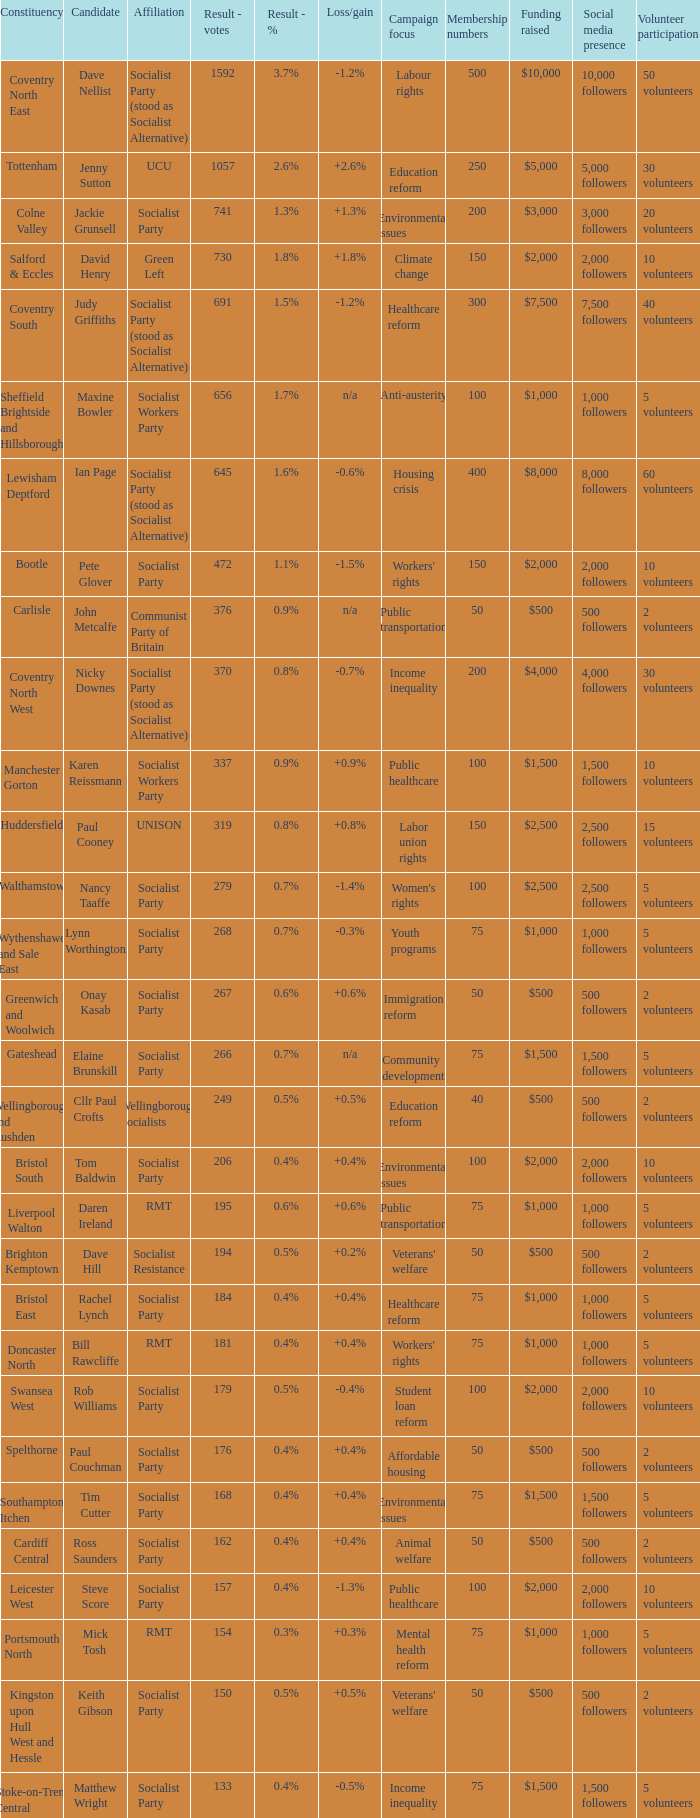How many values for constituency for the vote result of 162? 1.0. 